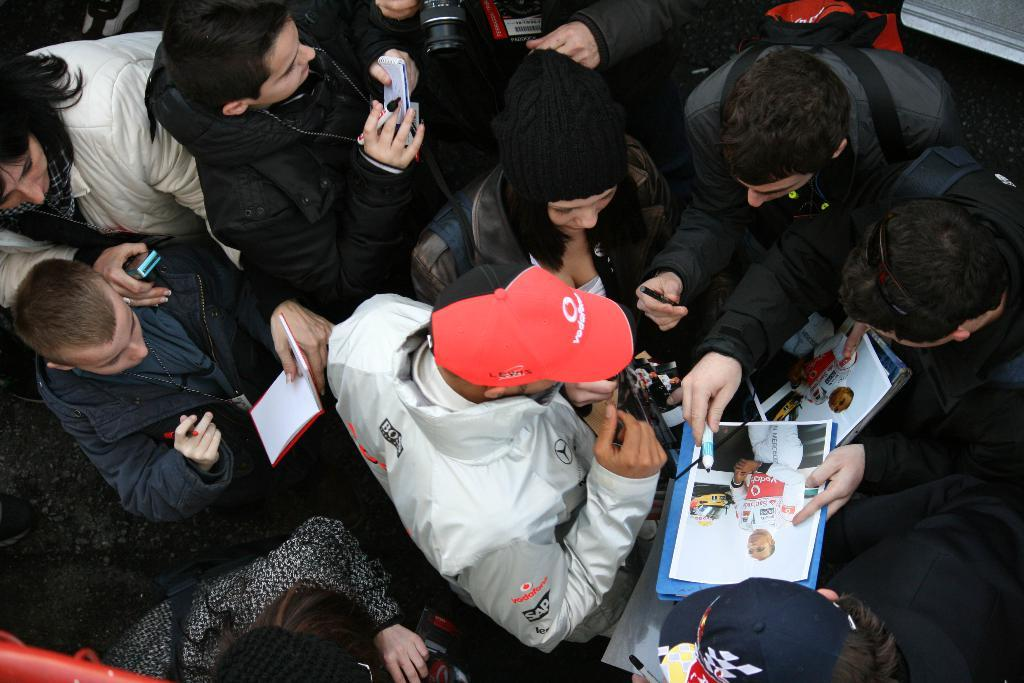Who or what is present in the image? There are people in the image. What are the people holding in their hands? The people are holding books and markers. What type of transport can be seen in the image? There is no transport visible in the image; it only features people holding books and markers. Can you describe the robin that is perched on the person's shoulder in the image? A: There is no robin present in the image; it only features people holding books and markers. 